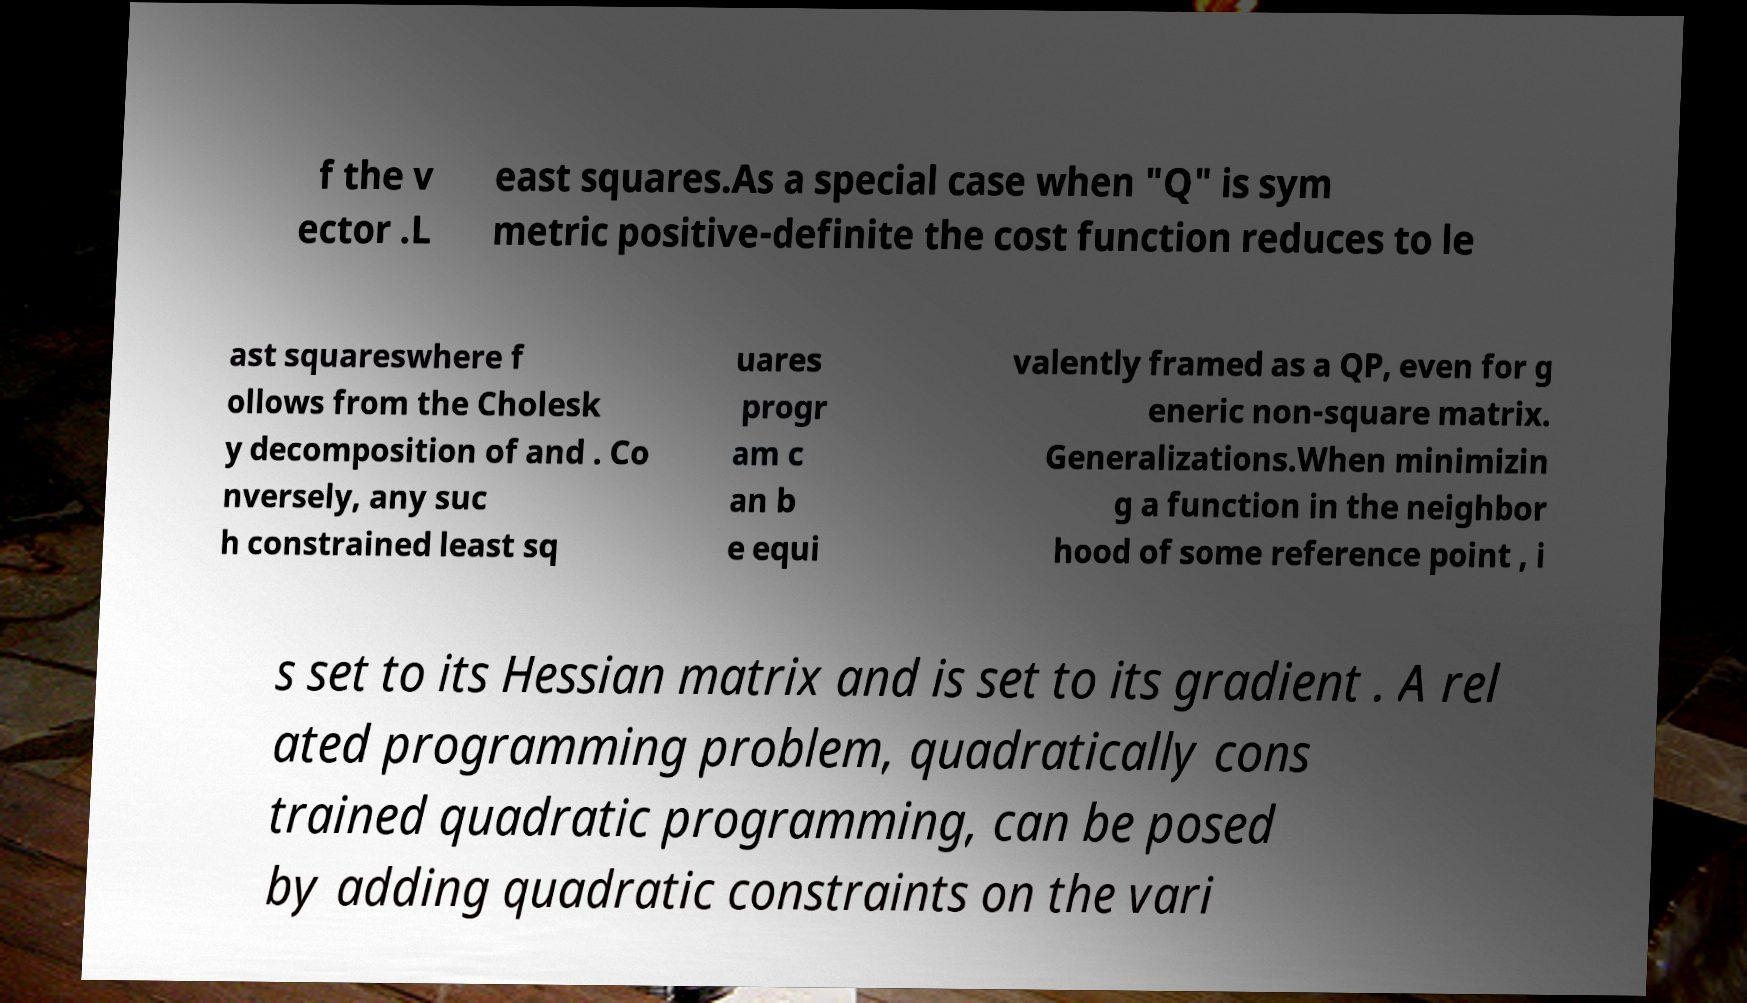For documentation purposes, I need the text within this image transcribed. Could you provide that? f the v ector .L east squares.As a special case when "Q" is sym metric positive-definite the cost function reduces to le ast squareswhere f ollows from the Cholesk y decomposition of and . Co nversely, any suc h constrained least sq uares progr am c an b e equi valently framed as a QP, even for g eneric non-square matrix. Generalizations.When minimizin g a function in the neighbor hood of some reference point , i s set to its Hessian matrix and is set to its gradient . A rel ated programming problem, quadratically cons trained quadratic programming, can be posed by adding quadratic constraints on the vari 